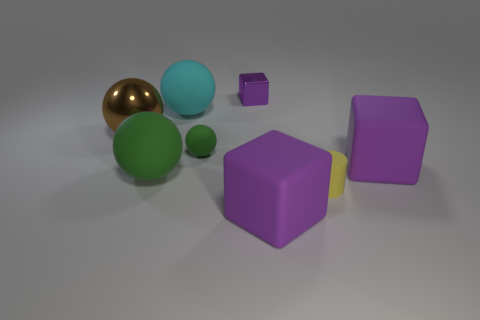Subtract 1 balls. How many balls are left? 3 Add 2 small yellow rubber cylinders. How many objects exist? 10 Subtract all cubes. How many objects are left? 5 Add 6 gray balls. How many gray balls exist? 6 Subtract 0 blue cylinders. How many objects are left? 8 Subtract all small purple rubber things. Subtract all big purple matte objects. How many objects are left? 6 Add 1 small metal objects. How many small metal objects are left? 2 